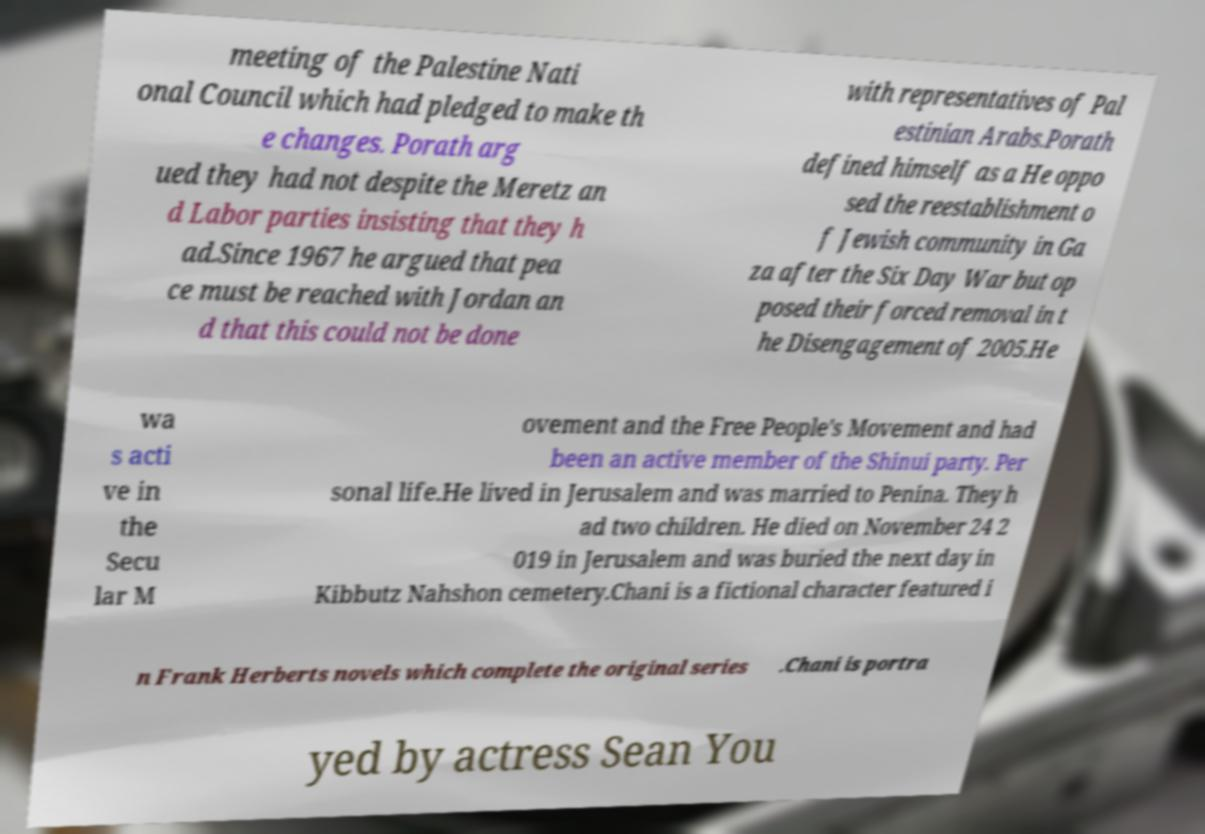Can you accurately transcribe the text from the provided image for me? meeting of the Palestine Nati onal Council which had pledged to make th e changes. Porath arg ued they had not despite the Meretz an d Labor parties insisting that they h ad.Since 1967 he argued that pea ce must be reached with Jordan an d that this could not be done with representatives of Pal estinian Arabs.Porath defined himself as a He oppo sed the reestablishment o f Jewish community in Ga za after the Six Day War but op posed their forced removal in t he Disengagement of 2005.He wa s acti ve in the Secu lar M ovement and the Free People's Movement and had been an active member of the Shinui party. Per sonal life.He lived in Jerusalem and was married to Penina. They h ad two children. He died on November 24 2 019 in Jerusalem and was buried the next day in Kibbutz Nahshon cemetery.Chani is a fictional character featured i n Frank Herberts novels which complete the original series .Chani is portra yed by actress Sean You 